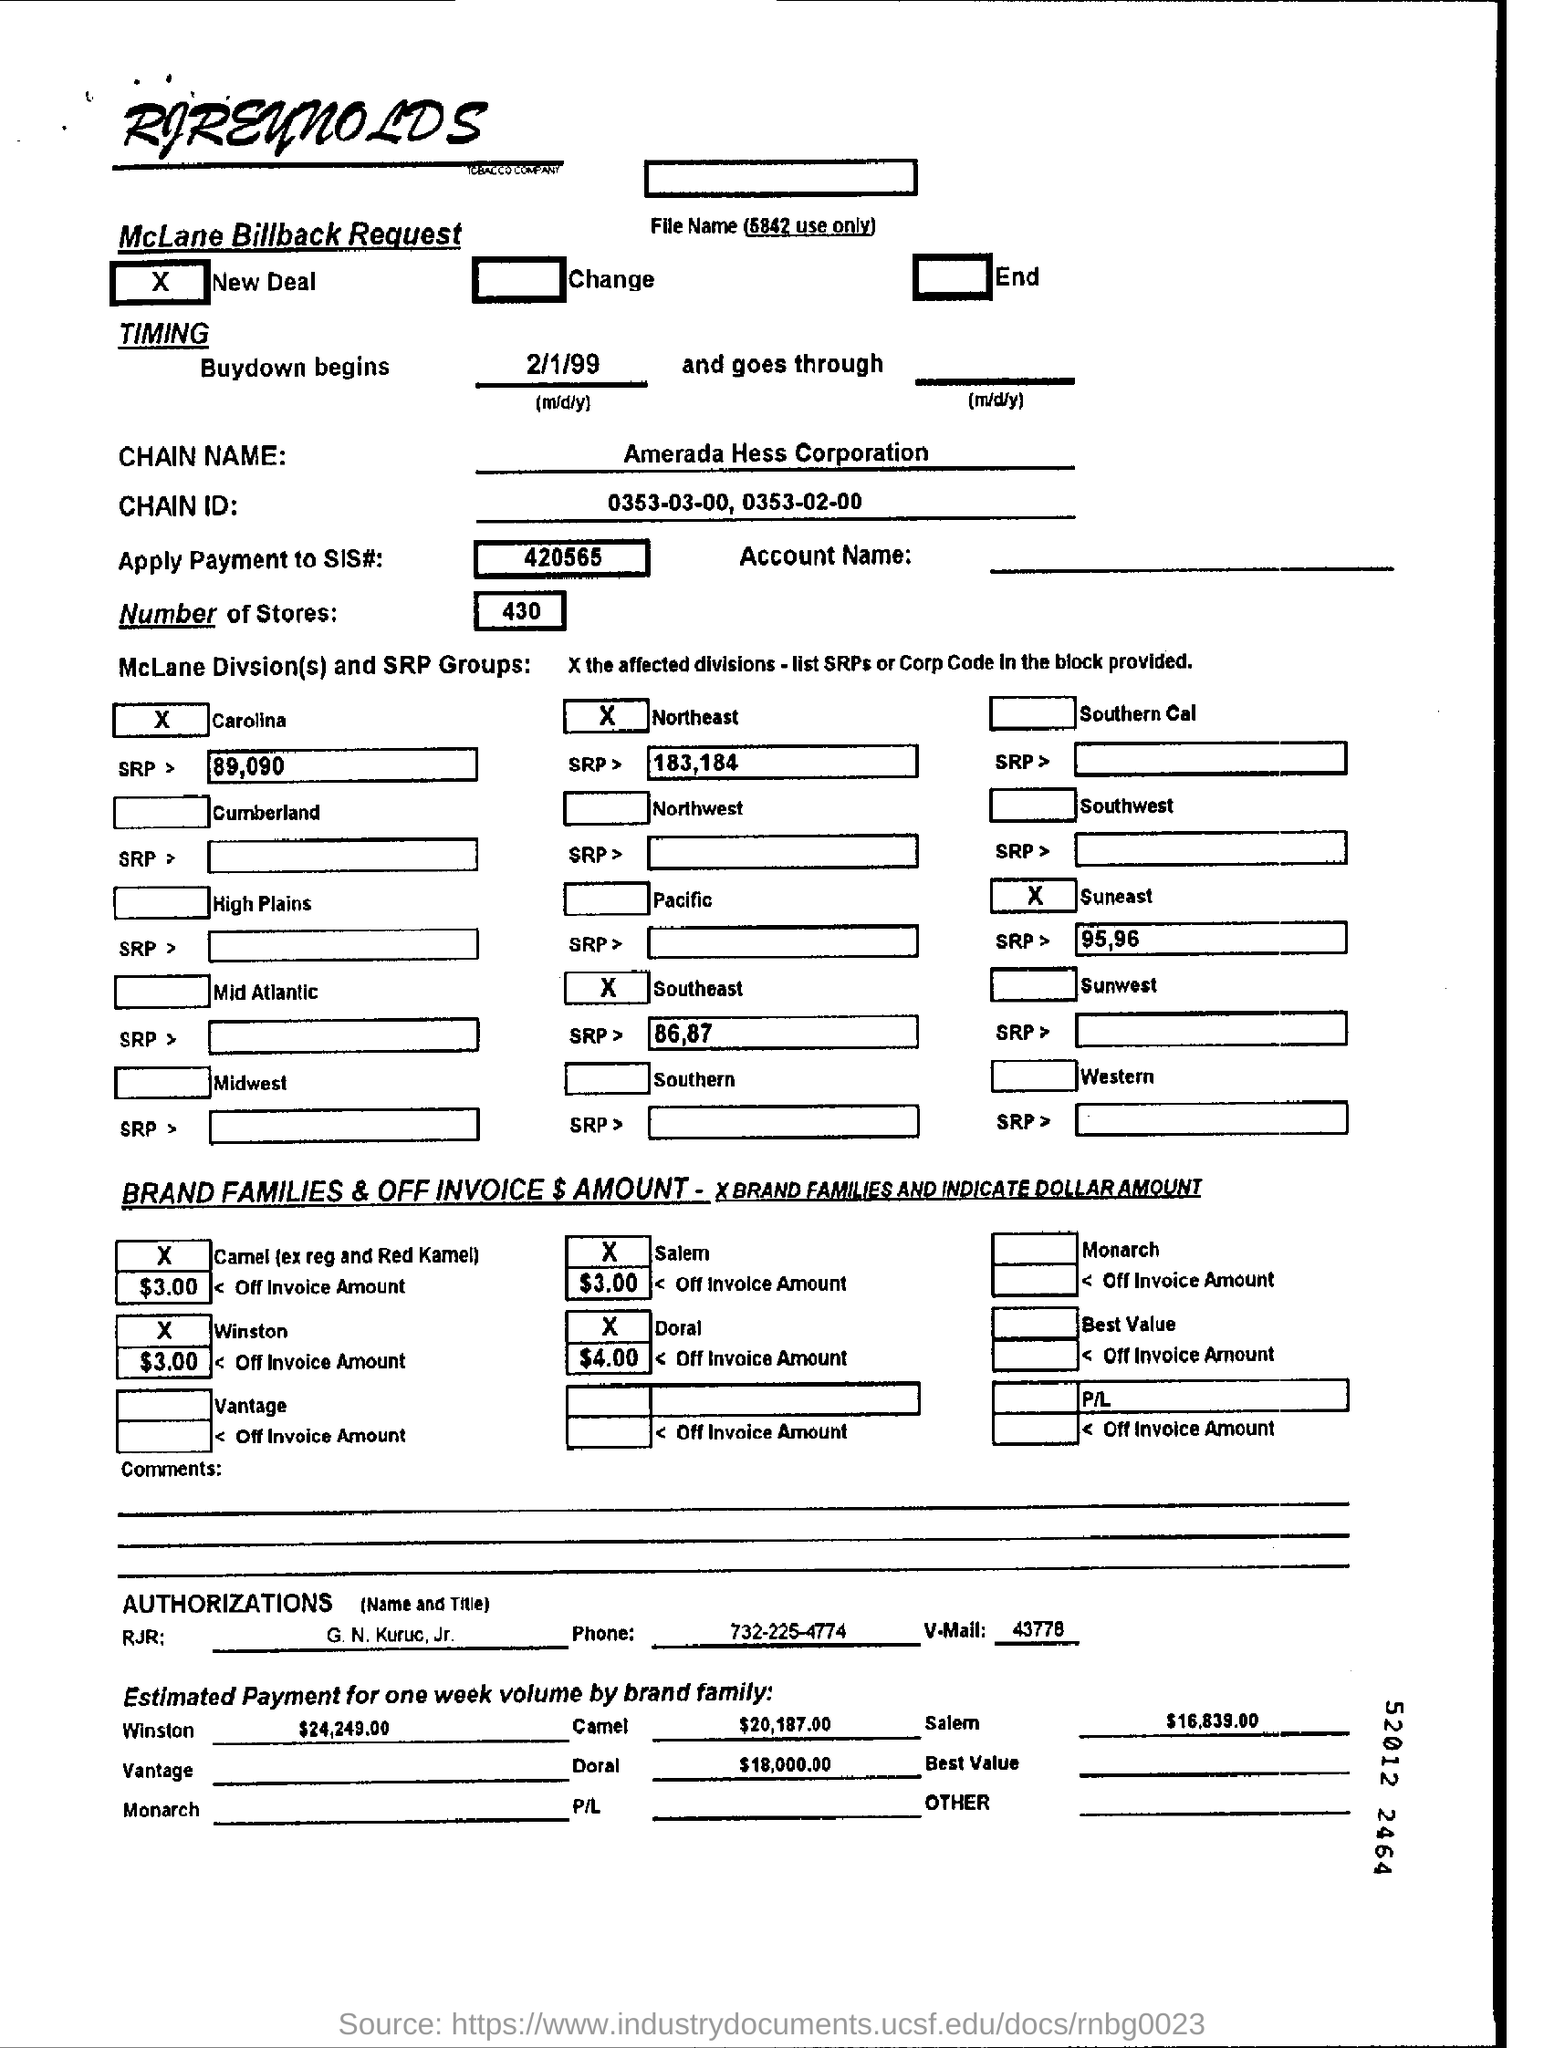What is the date given for buydown begins ?
Your response must be concise. 2/1/99. What is the chain name mentioned ?
Your response must be concise. Amerada Hess Corporation. What is the chain id mentioned ?
Keep it short and to the point. 0353-03-00 , 0353-02-00. What are the number of stores mentioned ?
Provide a short and direct response. 430. What is the number mentioned for apply payment to sis # ?
Offer a very short reply. 420565. What  is the phone no. mentioned ?
Make the answer very short. 732-225-4774. 